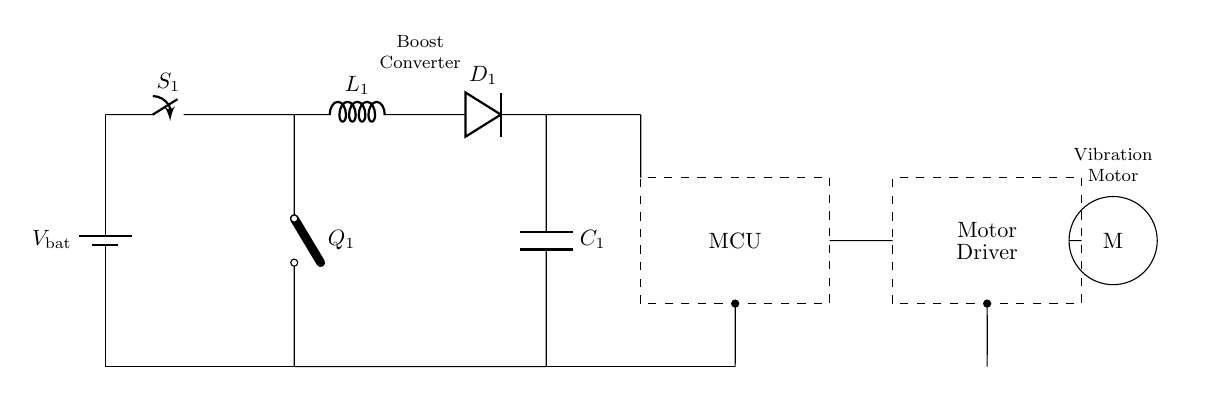What is the function of the switch S1? The switch S1 acts as a control mechanism for the circuit, allowing or interrupting the flow of current from the battery to the boost converter when it is opened or closed.
Answer: Control mechanism What component is responsible for voltage boosting? The boost converter, comprised of the inductor L1, diode D1, and capacitor C1, is responsible for increasing the voltage from the battery to a higher level suitable for the motor and microcontroller.
Answer: Boost converter How many main functional blocks are present in the circuit? The circuit contains three main functional blocks: the power management section (battery, switch, and boost converter), a microcontroller, and a vibration motor driver.
Answer: Three Which component provides feedback to the user? The vibration motor (M) provides feedback to the user through vibrations, acting as an output device based on signals received from the motor driver and controlled by the microcontroller.
Answer: Vibration motor What type of switching element is used for controlling the boost converter? A cute open switch Q1 is used for controlling the boost converter, allowing the circuit to manage energy transfer to the system intermittently.
Answer: Cute open switch How does the boost converter affect the system operation? The boost converter raises the voltage, allowing the microcontroller and motor driver to operate effectively, which is necessary for proper function of the vibration feedback system in portable applications.
Answer: Raises voltage 